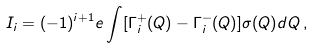<formula> <loc_0><loc_0><loc_500><loc_500>I _ { i } = ( - 1 ) ^ { i + 1 } e \int [ \Gamma ^ { + } _ { i } ( Q ) - \Gamma ^ { - } _ { i } ( Q ) ] \sigma ( Q ) d Q \, ,</formula> 